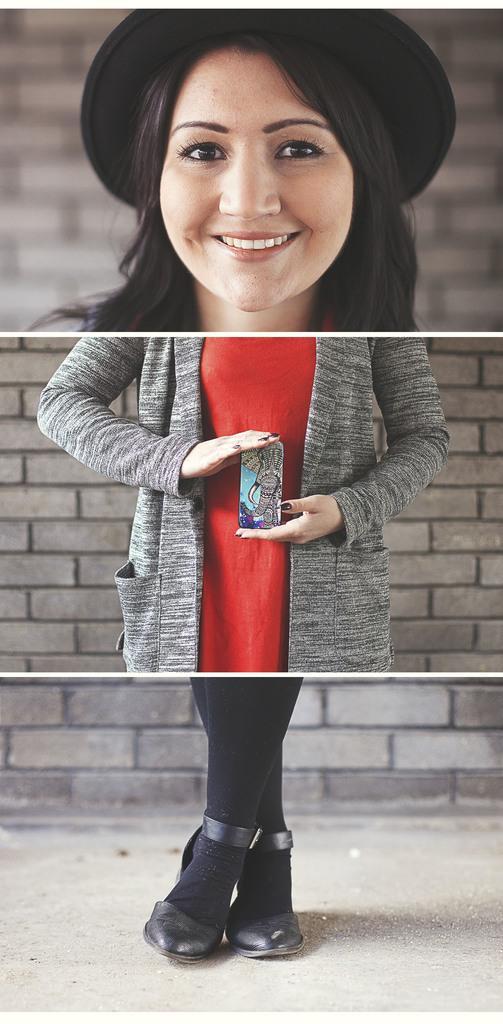How would you summarize this image in a sentence or two? It is a collage picture. In the image in the center we can see one woman standing and holding some object and she is wearing black color hat. In the background there is a brick wall. 